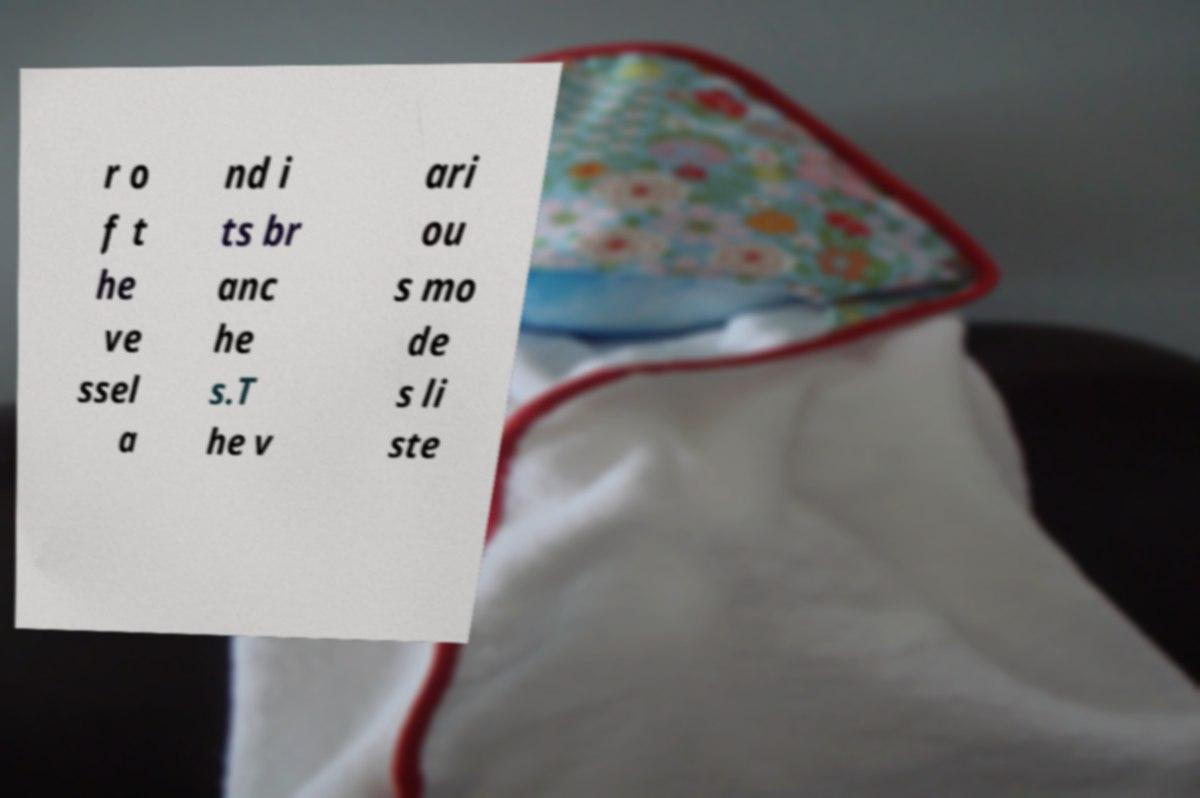Could you assist in decoding the text presented in this image and type it out clearly? r o f t he ve ssel a nd i ts br anc he s.T he v ari ou s mo de s li ste 